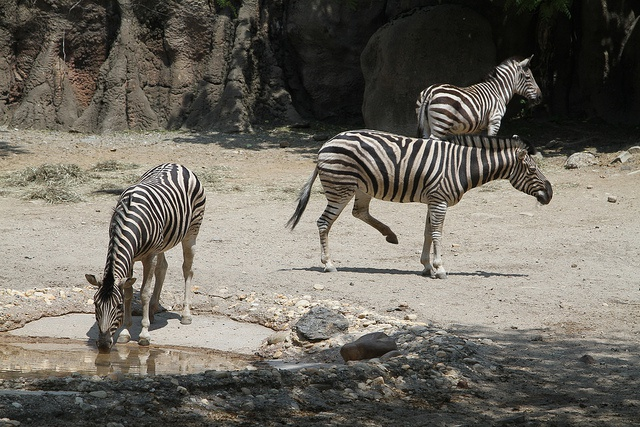Describe the objects in this image and their specific colors. I can see zebra in black, gray, and darkgray tones, zebra in black, gray, darkgray, and lightgray tones, and zebra in black, gray, darkgray, and lightgray tones in this image. 